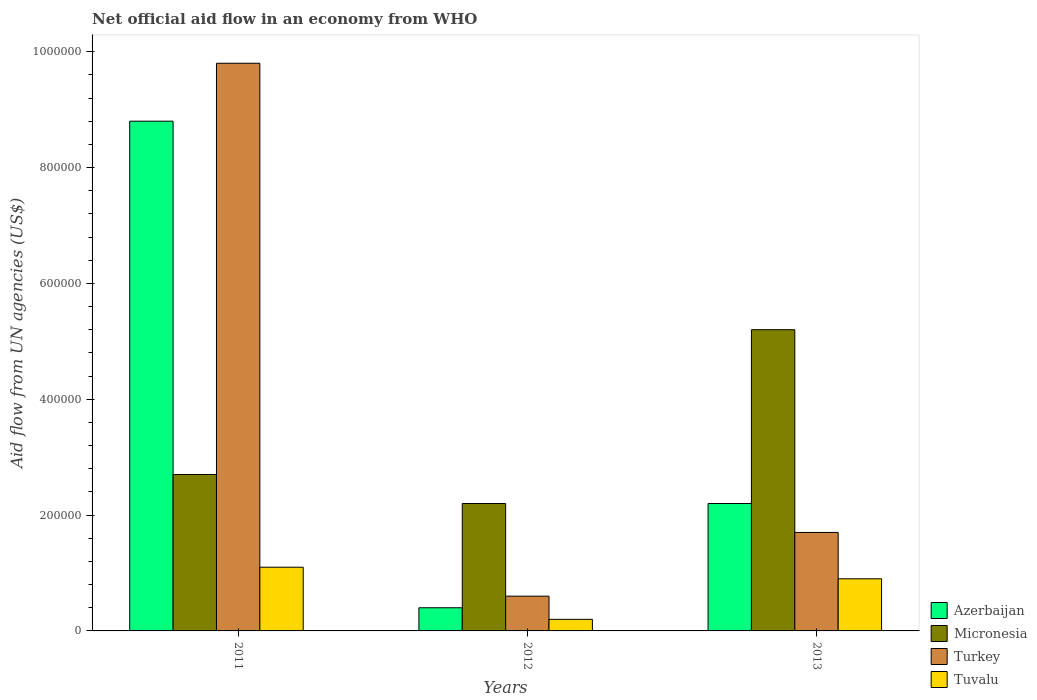How many different coloured bars are there?
Offer a terse response. 4. How many groups of bars are there?
Your answer should be compact. 3. Are the number of bars on each tick of the X-axis equal?
Provide a short and direct response. Yes. What is the label of the 2nd group of bars from the left?
Make the answer very short. 2012. In how many cases, is the number of bars for a given year not equal to the number of legend labels?
Make the answer very short. 0. What is the net official aid flow in Turkey in 2012?
Your answer should be very brief. 6.00e+04. Across all years, what is the maximum net official aid flow in Turkey?
Provide a succinct answer. 9.80e+05. What is the total net official aid flow in Azerbaijan in the graph?
Provide a succinct answer. 1.14e+06. What is the difference between the net official aid flow in Turkey in 2012 and the net official aid flow in Azerbaijan in 2013?
Offer a very short reply. -1.60e+05. What is the average net official aid flow in Micronesia per year?
Provide a succinct answer. 3.37e+05. What is the ratio of the net official aid flow in Tuvalu in 2011 to that in 2012?
Offer a very short reply. 5.5. What is the difference between the highest and the second highest net official aid flow in Turkey?
Keep it short and to the point. 8.10e+05. What is the difference between the highest and the lowest net official aid flow in Turkey?
Keep it short and to the point. 9.20e+05. In how many years, is the net official aid flow in Azerbaijan greater than the average net official aid flow in Azerbaijan taken over all years?
Your answer should be compact. 1. Is the sum of the net official aid flow in Azerbaijan in 2011 and 2012 greater than the maximum net official aid flow in Turkey across all years?
Offer a terse response. No. Is it the case that in every year, the sum of the net official aid flow in Micronesia and net official aid flow in Azerbaijan is greater than the sum of net official aid flow in Turkey and net official aid flow in Tuvalu?
Provide a succinct answer. Yes. What does the 1st bar from the right in 2013 represents?
Make the answer very short. Tuvalu. Is it the case that in every year, the sum of the net official aid flow in Micronesia and net official aid flow in Azerbaijan is greater than the net official aid flow in Turkey?
Your response must be concise. Yes. How many bars are there?
Offer a terse response. 12. Are the values on the major ticks of Y-axis written in scientific E-notation?
Make the answer very short. No. Does the graph contain any zero values?
Offer a terse response. No. Does the graph contain grids?
Your answer should be compact. No. How many legend labels are there?
Make the answer very short. 4. What is the title of the graph?
Your answer should be compact. Net official aid flow in an economy from WHO. Does "South Asia" appear as one of the legend labels in the graph?
Your answer should be very brief. No. What is the label or title of the Y-axis?
Provide a succinct answer. Aid flow from UN agencies (US$). What is the Aid flow from UN agencies (US$) in Azerbaijan in 2011?
Give a very brief answer. 8.80e+05. What is the Aid flow from UN agencies (US$) in Turkey in 2011?
Your answer should be very brief. 9.80e+05. What is the Aid flow from UN agencies (US$) in Azerbaijan in 2012?
Give a very brief answer. 4.00e+04. What is the Aid flow from UN agencies (US$) of Turkey in 2012?
Keep it short and to the point. 6.00e+04. What is the Aid flow from UN agencies (US$) in Tuvalu in 2012?
Your answer should be very brief. 2.00e+04. What is the Aid flow from UN agencies (US$) in Micronesia in 2013?
Keep it short and to the point. 5.20e+05. What is the Aid flow from UN agencies (US$) in Turkey in 2013?
Your response must be concise. 1.70e+05. What is the Aid flow from UN agencies (US$) in Tuvalu in 2013?
Make the answer very short. 9.00e+04. Across all years, what is the maximum Aid flow from UN agencies (US$) of Azerbaijan?
Keep it short and to the point. 8.80e+05. Across all years, what is the maximum Aid flow from UN agencies (US$) in Micronesia?
Offer a terse response. 5.20e+05. Across all years, what is the maximum Aid flow from UN agencies (US$) in Turkey?
Give a very brief answer. 9.80e+05. Across all years, what is the maximum Aid flow from UN agencies (US$) in Tuvalu?
Ensure brevity in your answer.  1.10e+05. What is the total Aid flow from UN agencies (US$) in Azerbaijan in the graph?
Offer a very short reply. 1.14e+06. What is the total Aid flow from UN agencies (US$) in Micronesia in the graph?
Your answer should be compact. 1.01e+06. What is the total Aid flow from UN agencies (US$) of Turkey in the graph?
Offer a very short reply. 1.21e+06. What is the difference between the Aid flow from UN agencies (US$) of Azerbaijan in 2011 and that in 2012?
Your answer should be compact. 8.40e+05. What is the difference between the Aid flow from UN agencies (US$) of Turkey in 2011 and that in 2012?
Your answer should be very brief. 9.20e+05. What is the difference between the Aid flow from UN agencies (US$) in Azerbaijan in 2011 and that in 2013?
Offer a very short reply. 6.60e+05. What is the difference between the Aid flow from UN agencies (US$) of Micronesia in 2011 and that in 2013?
Keep it short and to the point. -2.50e+05. What is the difference between the Aid flow from UN agencies (US$) in Turkey in 2011 and that in 2013?
Your response must be concise. 8.10e+05. What is the difference between the Aid flow from UN agencies (US$) in Azerbaijan in 2012 and that in 2013?
Ensure brevity in your answer.  -1.80e+05. What is the difference between the Aid flow from UN agencies (US$) in Micronesia in 2012 and that in 2013?
Give a very brief answer. -3.00e+05. What is the difference between the Aid flow from UN agencies (US$) in Tuvalu in 2012 and that in 2013?
Provide a succinct answer. -7.00e+04. What is the difference between the Aid flow from UN agencies (US$) in Azerbaijan in 2011 and the Aid flow from UN agencies (US$) in Micronesia in 2012?
Your answer should be compact. 6.60e+05. What is the difference between the Aid flow from UN agencies (US$) of Azerbaijan in 2011 and the Aid flow from UN agencies (US$) of Turkey in 2012?
Offer a very short reply. 8.20e+05. What is the difference between the Aid flow from UN agencies (US$) in Azerbaijan in 2011 and the Aid flow from UN agencies (US$) in Tuvalu in 2012?
Make the answer very short. 8.60e+05. What is the difference between the Aid flow from UN agencies (US$) of Micronesia in 2011 and the Aid flow from UN agencies (US$) of Turkey in 2012?
Provide a short and direct response. 2.10e+05. What is the difference between the Aid flow from UN agencies (US$) of Micronesia in 2011 and the Aid flow from UN agencies (US$) of Tuvalu in 2012?
Your answer should be compact. 2.50e+05. What is the difference between the Aid flow from UN agencies (US$) of Turkey in 2011 and the Aid flow from UN agencies (US$) of Tuvalu in 2012?
Offer a very short reply. 9.60e+05. What is the difference between the Aid flow from UN agencies (US$) of Azerbaijan in 2011 and the Aid flow from UN agencies (US$) of Micronesia in 2013?
Make the answer very short. 3.60e+05. What is the difference between the Aid flow from UN agencies (US$) of Azerbaijan in 2011 and the Aid flow from UN agencies (US$) of Turkey in 2013?
Your answer should be very brief. 7.10e+05. What is the difference between the Aid flow from UN agencies (US$) in Azerbaijan in 2011 and the Aid flow from UN agencies (US$) in Tuvalu in 2013?
Your answer should be compact. 7.90e+05. What is the difference between the Aid flow from UN agencies (US$) of Turkey in 2011 and the Aid flow from UN agencies (US$) of Tuvalu in 2013?
Your response must be concise. 8.90e+05. What is the difference between the Aid flow from UN agencies (US$) of Azerbaijan in 2012 and the Aid flow from UN agencies (US$) of Micronesia in 2013?
Ensure brevity in your answer.  -4.80e+05. What is the difference between the Aid flow from UN agencies (US$) of Azerbaijan in 2012 and the Aid flow from UN agencies (US$) of Turkey in 2013?
Provide a short and direct response. -1.30e+05. What is the difference between the Aid flow from UN agencies (US$) of Micronesia in 2012 and the Aid flow from UN agencies (US$) of Tuvalu in 2013?
Your response must be concise. 1.30e+05. What is the difference between the Aid flow from UN agencies (US$) in Turkey in 2012 and the Aid flow from UN agencies (US$) in Tuvalu in 2013?
Provide a succinct answer. -3.00e+04. What is the average Aid flow from UN agencies (US$) of Micronesia per year?
Offer a terse response. 3.37e+05. What is the average Aid flow from UN agencies (US$) of Turkey per year?
Ensure brevity in your answer.  4.03e+05. What is the average Aid flow from UN agencies (US$) in Tuvalu per year?
Your answer should be very brief. 7.33e+04. In the year 2011, what is the difference between the Aid flow from UN agencies (US$) in Azerbaijan and Aid flow from UN agencies (US$) in Micronesia?
Offer a very short reply. 6.10e+05. In the year 2011, what is the difference between the Aid flow from UN agencies (US$) of Azerbaijan and Aid flow from UN agencies (US$) of Turkey?
Offer a terse response. -1.00e+05. In the year 2011, what is the difference between the Aid flow from UN agencies (US$) of Azerbaijan and Aid flow from UN agencies (US$) of Tuvalu?
Offer a very short reply. 7.70e+05. In the year 2011, what is the difference between the Aid flow from UN agencies (US$) in Micronesia and Aid flow from UN agencies (US$) in Turkey?
Provide a succinct answer. -7.10e+05. In the year 2011, what is the difference between the Aid flow from UN agencies (US$) of Micronesia and Aid flow from UN agencies (US$) of Tuvalu?
Your answer should be very brief. 1.60e+05. In the year 2011, what is the difference between the Aid flow from UN agencies (US$) of Turkey and Aid flow from UN agencies (US$) of Tuvalu?
Make the answer very short. 8.70e+05. In the year 2012, what is the difference between the Aid flow from UN agencies (US$) of Azerbaijan and Aid flow from UN agencies (US$) of Micronesia?
Your response must be concise. -1.80e+05. In the year 2012, what is the difference between the Aid flow from UN agencies (US$) in Micronesia and Aid flow from UN agencies (US$) in Turkey?
Provide a succinct answer. 1.60e+05. In the year 2012, what is the difference between the Aid flow from UN agencies (US$) in Micronesia and Aid flow from UN agencies (US$) in Tuvalu?
Keep it short and to the point. 2.00e+05. In the year 2012, what is the difference between the Aid flow from UN agencies (US$) of Turkey and Aid flow from UN agencies (US$) of Tuvalu?
Your response must be concise. 4.00e+04. In the year 2013, what is the difference between the Aid flow from UN agencies (US$) in Azerbaijan and Aid flow from UN agencies (US$) in Turkey?
Provide a short and direct response. 5.00e+04. In the year 2013, what is the difference between the Aid flow from UN agencies (US$) of Turkey and Aid flow from UN agencies (US$) of Tuvalu?
Your response must be concise. 8.00e+04. What is the ratio of the Aid flow from UN agencies (US$) in Azerbaijan in 2011 to that in 2012?
Keep it short and to the point. 22. What is the ratio of the Aid flow from UN agencies (US$) of Micronesia in 2011 to that in 2012?
Ensure brevity in your answer.  1.23. What is the ratio of the Aid flow from UN agencies (US$) of Turkey in 2011 to that in 2012?
Provide a short and direct response. 16.33. What is the ratio of the Aid flow from UN agencies (US$) of Tuvalu in 2011 to that in 2012?
Your response must be concise. 5.5. What is the ratio of the Aid flow from UN agencies (US$) of Micronesia in 2011 to that in 2013?
Make the answer very short. 0.52. What is the ratio of the Aid flow from UN agencies (US$) in Turkey in 2011 to that in 2013?
Your answer should be compact. 5.76. What is the ratio of the Aid flow from UN agencies (US$) of Tuvalu in 2011 to that in 2013?
Your answer should be very brief. 1.22. What is the ratio of the Aid flow from UN agencies (US$) of Azerbaijan in 2012 to that in 2013?
Your response must be concise. 0.18. What is the ratio of the Aid flow from UN agencies (US$) of Micronesia in 2012 to that in 2013?
Offer a terse response. 0.42. What is the ratio of the Aid flow from UN agencies (US$) of Turkey in 2012 to that in 2013?
Offer a very short reply. 0.35. What is the ratio of the Aid flow from UN agencies (US$) in Tuvalu in 2012 to that in 2013?
Your response must be concise. 0.22. What is the difference between the highest and the second highest Aid flow from UN agencies (US$) in Turkey?
Give a very brief answer. 8.10e+05. What is the difference between the highest and the lowest Aid flow from UN agencies (US$) of Azerbaijan?
Give a very brief answer. 8.40e+05. What is the difference between the highest and the lowest Aid flow from UN agencies (US$) of Turkey?
Give a very brief answer. 9.20e+05. What is the difference between the highest and the lowest Aid flow from UN agencies (US$) in Tuvalu?
Give a very brief answer. 9.00e+04. 